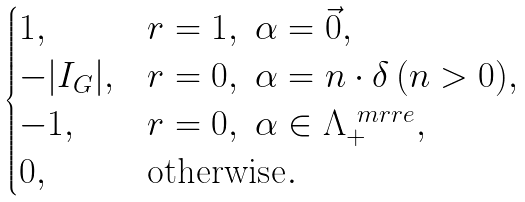Convert formula to latex. <formula><loc_0><loc_0><loc_500><loc_500>\begin{cases} 1 , & r = 1 , \ \alpha = \vec { 0 } , \\ - | I _ { G } | , & r = 0 , \ \alpha = n \cdot \delta \, ( n > 0 ) , \\ - 1 , & r = 0 , \ \alpha \in \Lambda _ { + } ^ { \ m r { r e } } , \\ 0 , & \text {otherwise} . \end{cases}</formula> 